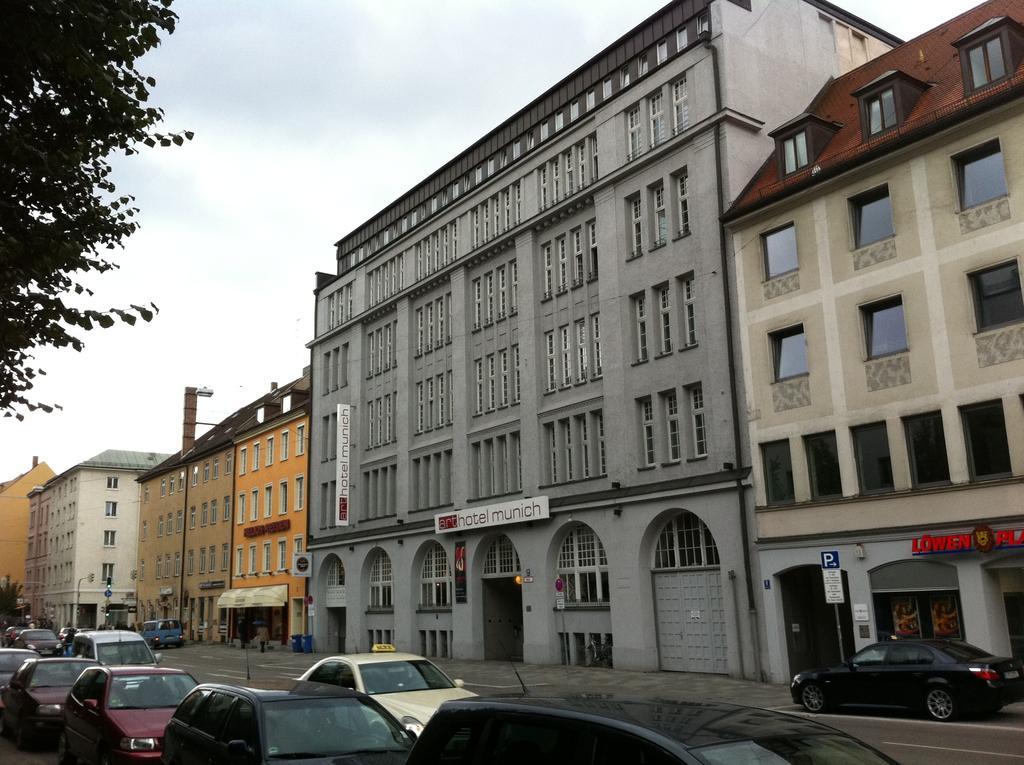Please provide a concise description of this image. In the foreground of the image we can see group of vehicles parked on the road. In the background, we can see a group of buildings with windows and sign boards with text on them, trees and the sky. 